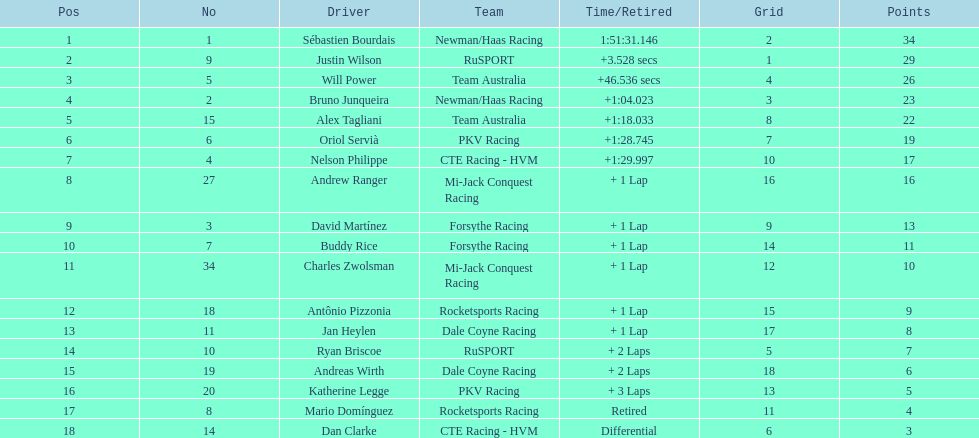Can you parse all the data within this table? {'header': ['Pos', 'No', 'Driver', 'Team', 'Time/Retired', 'Grid', 'Points'], 'rows': [['1', '1', 'Sébastien Bourdais', 'Newman/Haas Racing', '1:51:31.146', '2', '34'], ['2', '9', 'Justin Wilson', 'RuSPORT', '+3.528 secs', '1', '29'], ['3', '5', 'Will Power', 'Team Australia', '+46.536 secs', '4', '26'], ['4', '2', 'Bruno Junqueira', 'Newman/Haas Racing', '+1:04.023', '3', '23'], ['5', '15', 'Alex Tagliani', 'Team Australia', '+1:18.033', '8', '22'], ['6', '6', 'Oriol Servià', 'PKV Racing', '+1:28.745', '7', '19'], ['7', '4', 'Nelson Philippe', 'CTE Racing - HVM', '+1:29.997', '10', '17'], ['8', '27', 'Andrew Ranger', 'Mi-Jack Conquest Racing', '+ 1 Lap', '16', '16'], ['9', '3', 'David Martínez', 'Forsythe Racing', '+ 1 Lap', '9', '13'], ['10', '7', 'Buddy Rice', 'Forsythe Racing', '+ 1 Lap', '14', '11'], ['11', '34', 'Charles Zwolsman', 'Mi-Jack Conquest Racing', '+ 1 Lap', '12', '10'], ['12', '18', 'Antônio Pizzonia', 'Rocketsports Racing', '+ 1 Lap', '15', '9'], ['13', '11', 'Jan Heylen', 'Dale Coyne Racing', '+ 1 Lap', '17', '8'], ['14', '10', 'Ryan Briscoe', 'RuSPORT', '+ 2 Laps', '5', '7'], ['15', '19', 'Andreas Wirth', 'Dale Coyne Racing', '+ 2 Laps', '18', '6'], ['16', '20', 'Katherine Legge', 'PKV Racing', '+ 3 Laps', '13', '5'], ['17', '8', 'Mario Domínguez', 'Rocketsports Racing', 'Retired', '11', '4'], ['18', '14', 'Dan Clarke', 'CTE Racing - HVM', 'Differential', '6', '3']]} At the 2006 gran premio telmex, who finished last? Dan Clarke. 